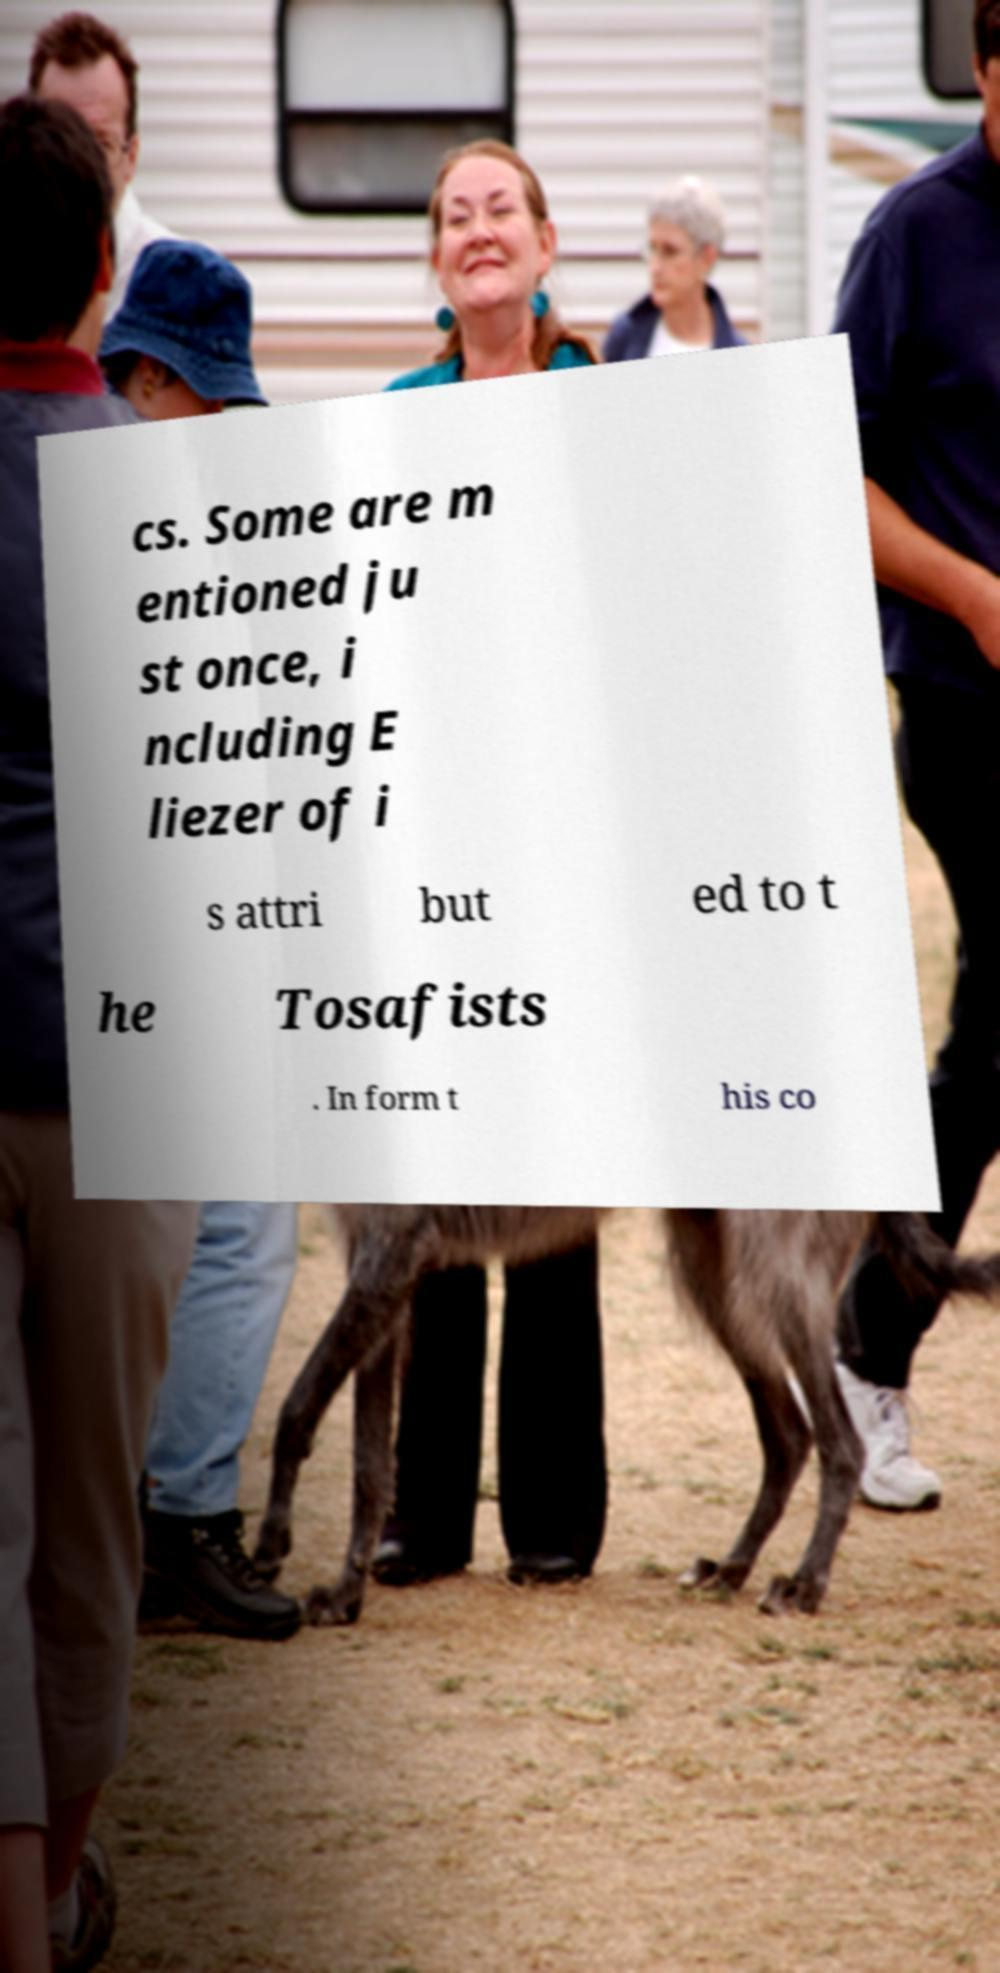Please identify and transcribe the text found in this image. cs. Some are m entioned ju st once, i ncluding E liezer of i s attri but ed to t he Tosafists . In form t his co 